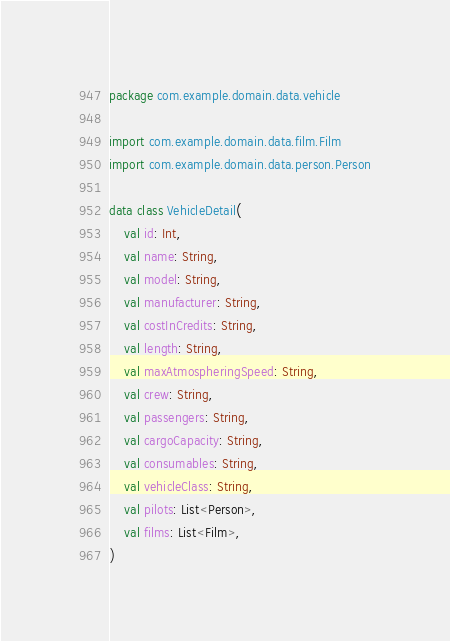Convert code to text. <code><loc_0><loc_0><loc_500><loc_500><_Kotlin_>package com.example.domain.data.vehicle

import com.example.domain.data.film.Film
import com.example.domain.data.person.Person

data class VehicleDetail(
    val id: Int,
    val name: String,
    val model: String,
    val manufacturer: String,
    val costInCredits: String,
    val length: String,
    val maxAtmospheringSpeed: String,
    val crew: String,
    val passengers: String,
    val cargoCapacity: String,
    val consumables: String,
    val vehicleClass: String,
    val pilots: List<Person>,
    val films: List<Film>,
)
</code> 